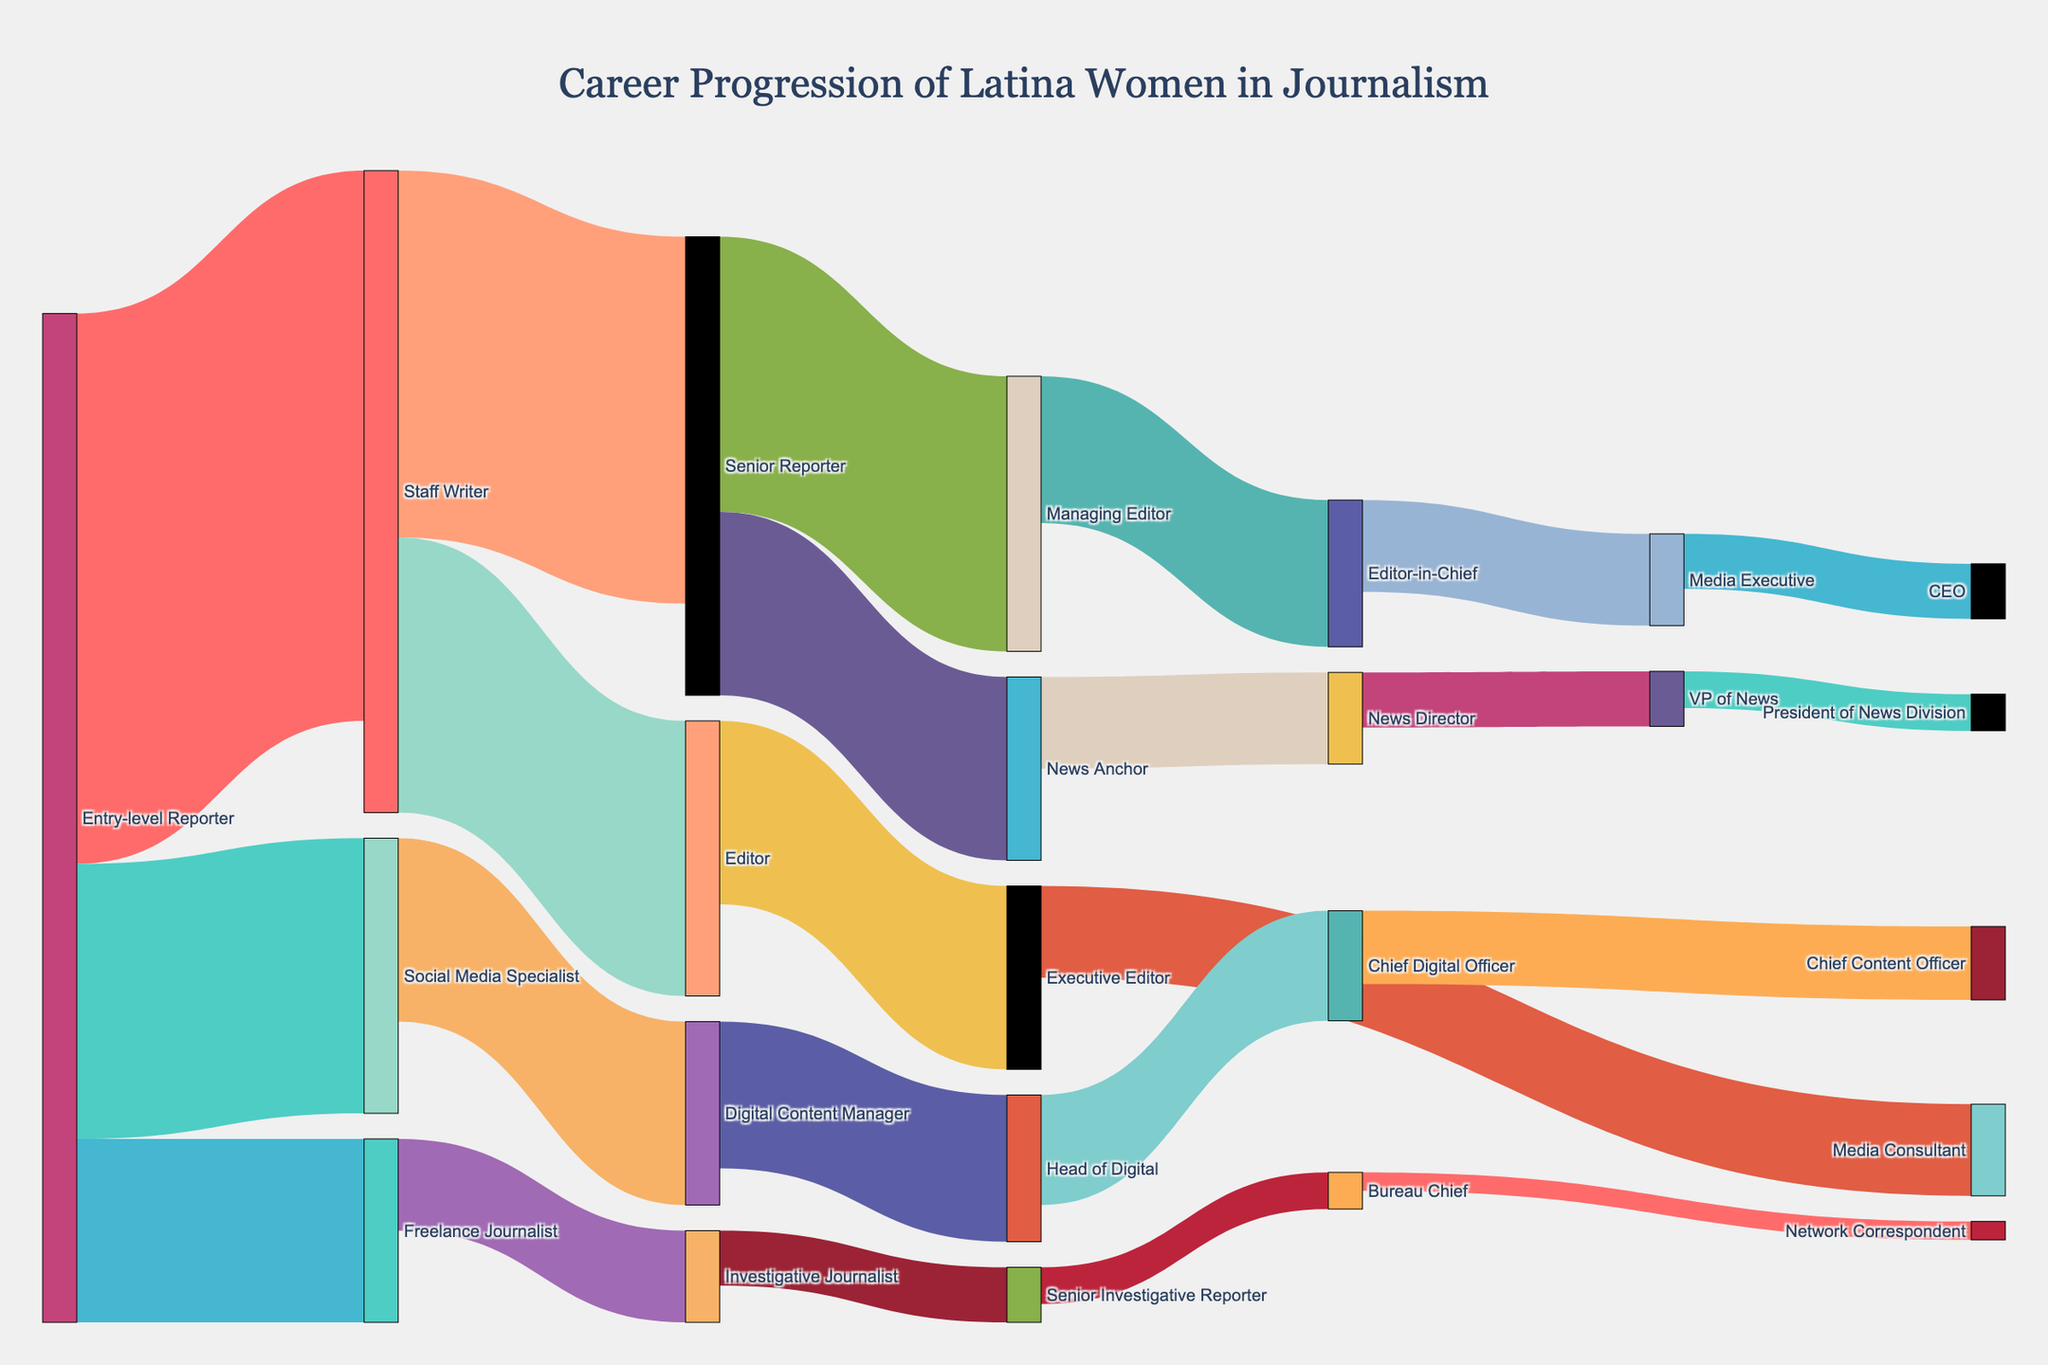What is the title of the Sankey diagram? The title is located at the top center of the figure. It is in a larger and distinct font. The title states the main subject or description of the figure.
Answer: "Career Progression of Latina Women in Journalism" Which entry-level career path has the highest number of Latina women transitioning to it? Look at the links that start from "Entry-level Reporter" and identify the ones with the highest value.
Answer: Staff Writer How many Latina women transition from Digital Content Manager to Head of Digital? Find the flow labeled "Digital Content Manager" that leads to "Head of Digital" and check its value.
Answer: 8 Which role does Senior Reporter lead to the most frequently? Look at the links originating from "Senior Reporter" and compare the values to identify the highest one.
Answer: Managing Editor What is the total number of Latina women who transition to leadership roles from Editor? Sum the values of the links from "Editor" to its target states. There is only one transition: "Editor" to "Executive Editor."
Answer: 10 What leadership roles do Latina women typically achieve after being Managing Editor? Identify the target nodes that receive flow from "Managing Editor." There is one direct link which denotes a higher leadership role.
Answer: Editor-in-Chief Which role has the highest number of Latina women transitioning into from Social Media Specialist? Examine the paths originating from "Social Media Specialist" and identify the one with the highest value.
Answer: Digital Content Manager What is the sum of Latina women who reach roles like Media Consultant, Chief Digital Officer, Bureau Chief, VP of News, and CEO? Add the values for each of these roles. Specifically, sum 5 (Media Consultant) + 6 (Chief Digital Officer) + 2 (Bureau Chief) + 3 (VP of News) + 3 (CEO).
Answer: 19 Which path represents the least number of Latina women transitioning to a role from each preceding position? Identify the link that has the smallest value. In this case, the smallest transition value is 1.
Answer: Bureau Chief to Network Correspondent 